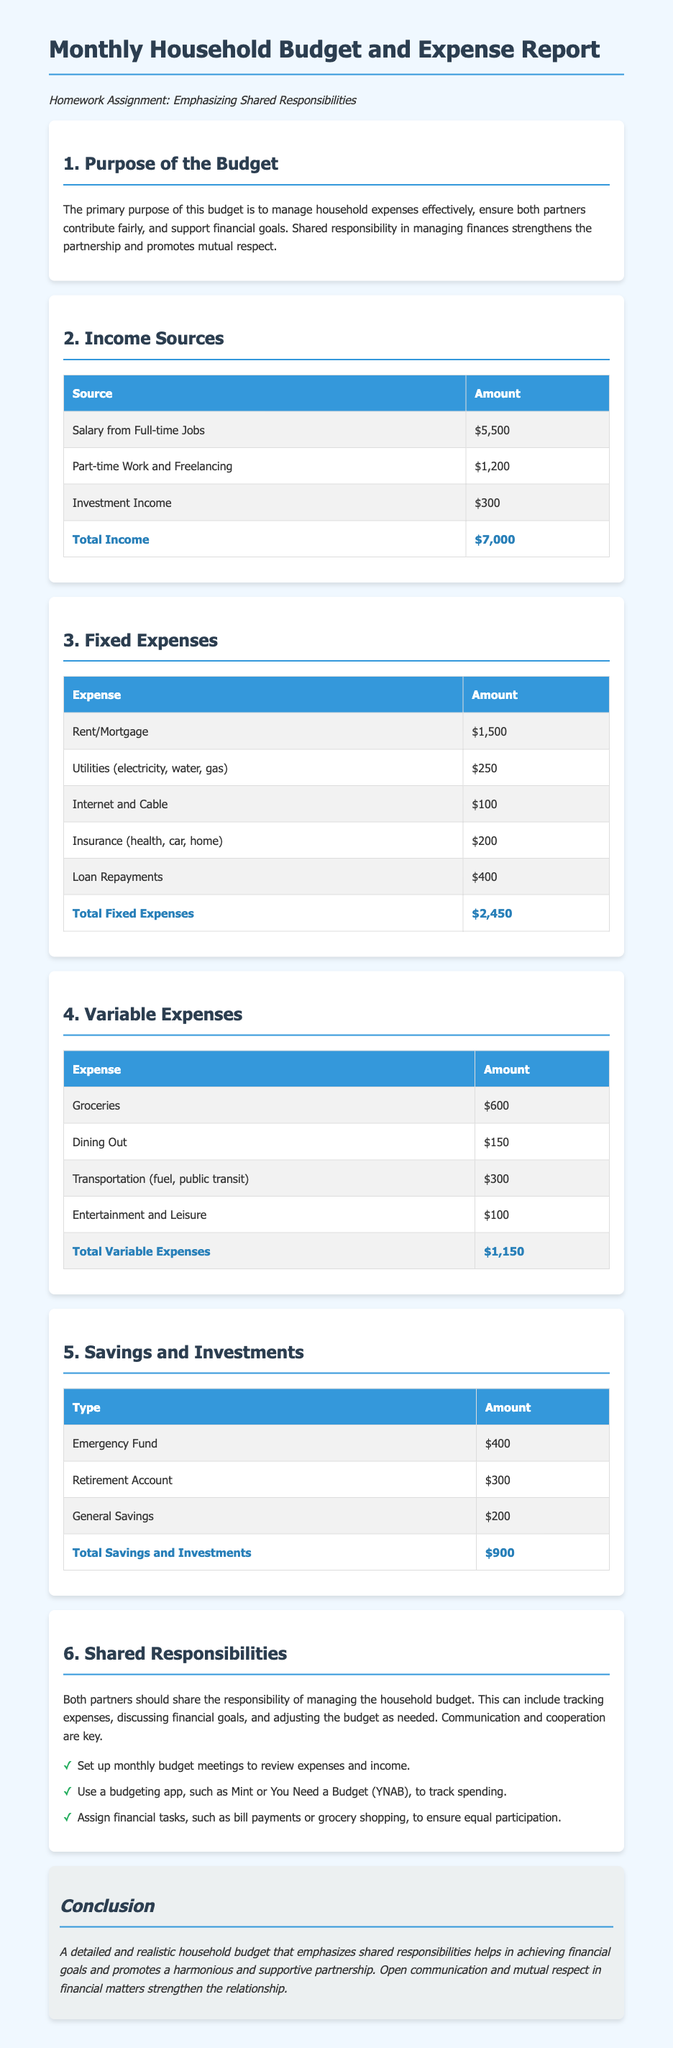What is the total income? The total income is calculated by adding all income sources listed in the document, which are $5,500 + $1,200 + $300 = $7,000.
Answer: $7,000 What is the total of fixed expenses? The total fixed expenses are the sum of all fixed expenses in the document, which is $1,500 + $250 + $100 + $200 + $400 = $2,450.
Answer: $2,450 What are the three types of savings listed? The document lists Emergency Fund, Retirement Account, and General Savings as three types of savings.
Answer: Emergency Fund, Retirement Account, General Savings What is emphasized in the purpose of the budget? The purpose of the budget emphasizes managing household expenses effectively, ensuring fair contributions, and supporting financial goals.
Answer: Shared responsibility How much is allocated for groceries in variable expenses? The amount allocated for groceries as stated in the variable expenses section of the document is $600.
Answer: $600 What is a suggested tool for tracking spending? The document suggests using budgeting apps like Mint or You Need a Budget (YNAB) for tracking spending.
Answer: Budgeting app What should partners do according to shared responsibilities? Partners should share responsibilities by tracking expenses and discussing financial goals as highlighted in the document.
Answer: Cooperate and communicate How much is allocated for savings in the retirement account? The allocation for the retirement account as stated in the savings section is $300.
Answer: $300 What is the conclusion's main point? The main point of the conclusion emphasizes the importance of detailed budgeting and shared responsibilities in strengthening relationships.
Answer: Open communication and mutual respect 